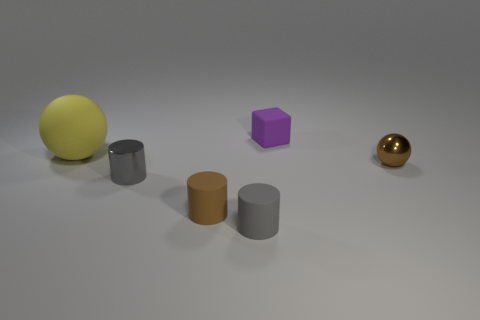Add 1 cylinders. How many objects exist? 7 Subtract all blocks. How many objects are left? 5 Add 5 red rubber cylinders. How many red rubber cylinders exist? 5 Subtract 0 green cylinders. How many objects are left? 6 Subtract all small gray rubber cylinders. Subtract all blocks. How many objects are left? 4 Add 3 small purple objects. How many small purple objects are left? 4 